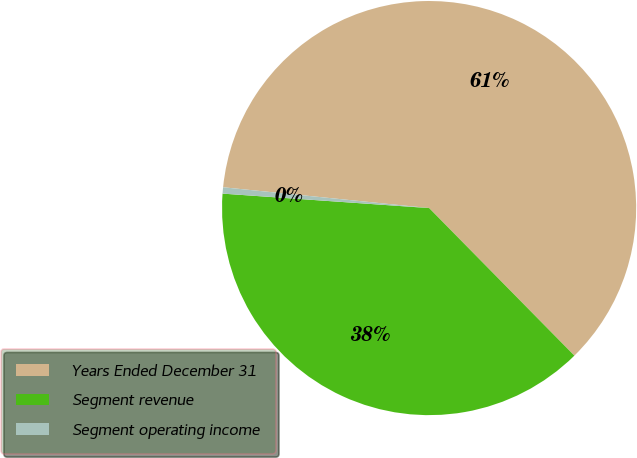Convert chart. <chart><loc_0><loc_0><loc_500><loc_500><pie_chart><fcel>Years Ended December 31<fcel>Segment revenue<fcel>Segment operating income<nl><fcel>61.03%<fcel>38.49%<fcel>0.49%<nl></chart> 